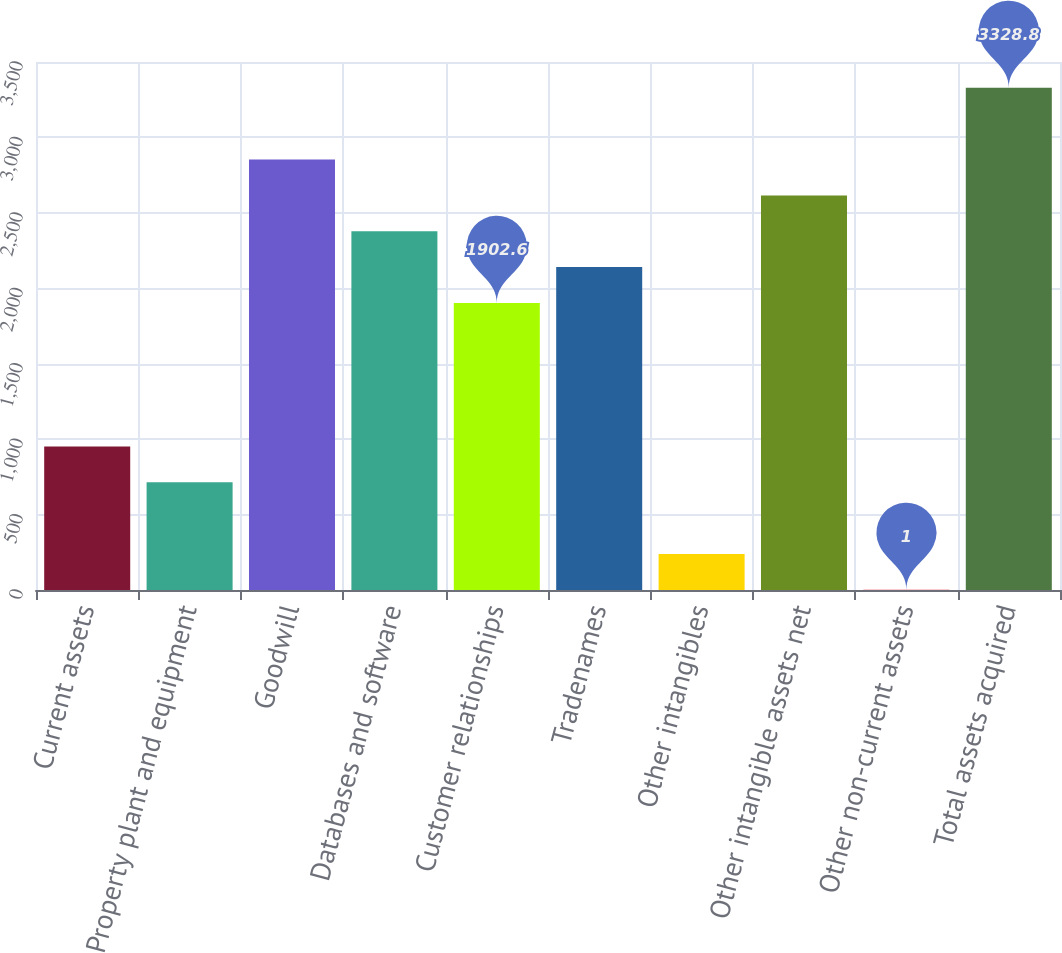Convert chart to OTSL. <chart><loc_0><loc_0><loc_500><loc_500><bar_chart><fcel>Current assets<fcel>Property plant and equipment<fcel>Goodwill<fcel>Databases and software<fcel>Customer relationships<fcel>Tradenames<fcel>Other intangibles<fcel>Other intangible assets net<fcel>Other non-current assets<fcel>Total assets acquired<nl><fcel>951.8<fcel>714.1<fcel>2853.4<fcel>2378<fcel>1902.6<fcel>2140.3<fcel>238.7<fcel>2615.7<fcel>1<fcel>3328.8<nl></chart> 